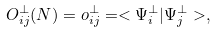Convert formula to latex. <formula><loc_0><loc_0><loc_500><loc_500>O ^ { \bot } _ { i j } ( N ) = o ^ { \bot } _ { i j } = < \Psi _ { i } ^ { \bot } | \Psi ^ { \bot } _ { j } > ,</formula> 